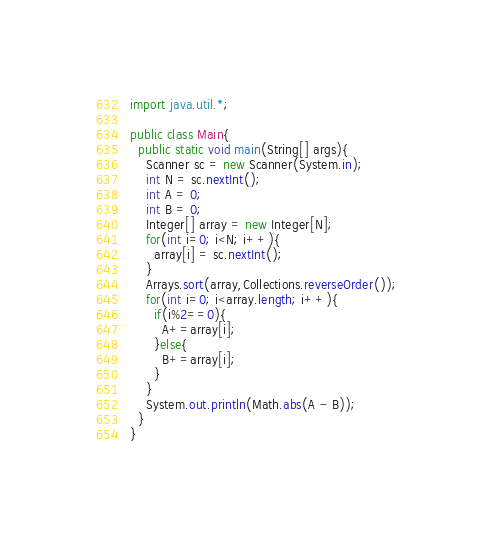<code> <loc_0><loc_0><loc_500><loc_500><_Java_>import java.util.*;

public class Main{
  public static void main(String[] args){
    Scanner sc = new Scanner(System.in);
    int N = sc.nextInt();
    int A = 0;
    int B = 0;
    Integer[] array = new Integer[N];
    for(int i=0; i<N; i++){
      array[i] = sc.nextInt();
    }
    Arrays.sort(array,Collections.reverseOrder());
    for(int i=0; i<array.length; i++){
      if(i%2==0){
        A+=array[i];
      }else{
        B+=array[i];
      }
    }
    System.out.println(Math.abs(A - B));
  }
}</code> 